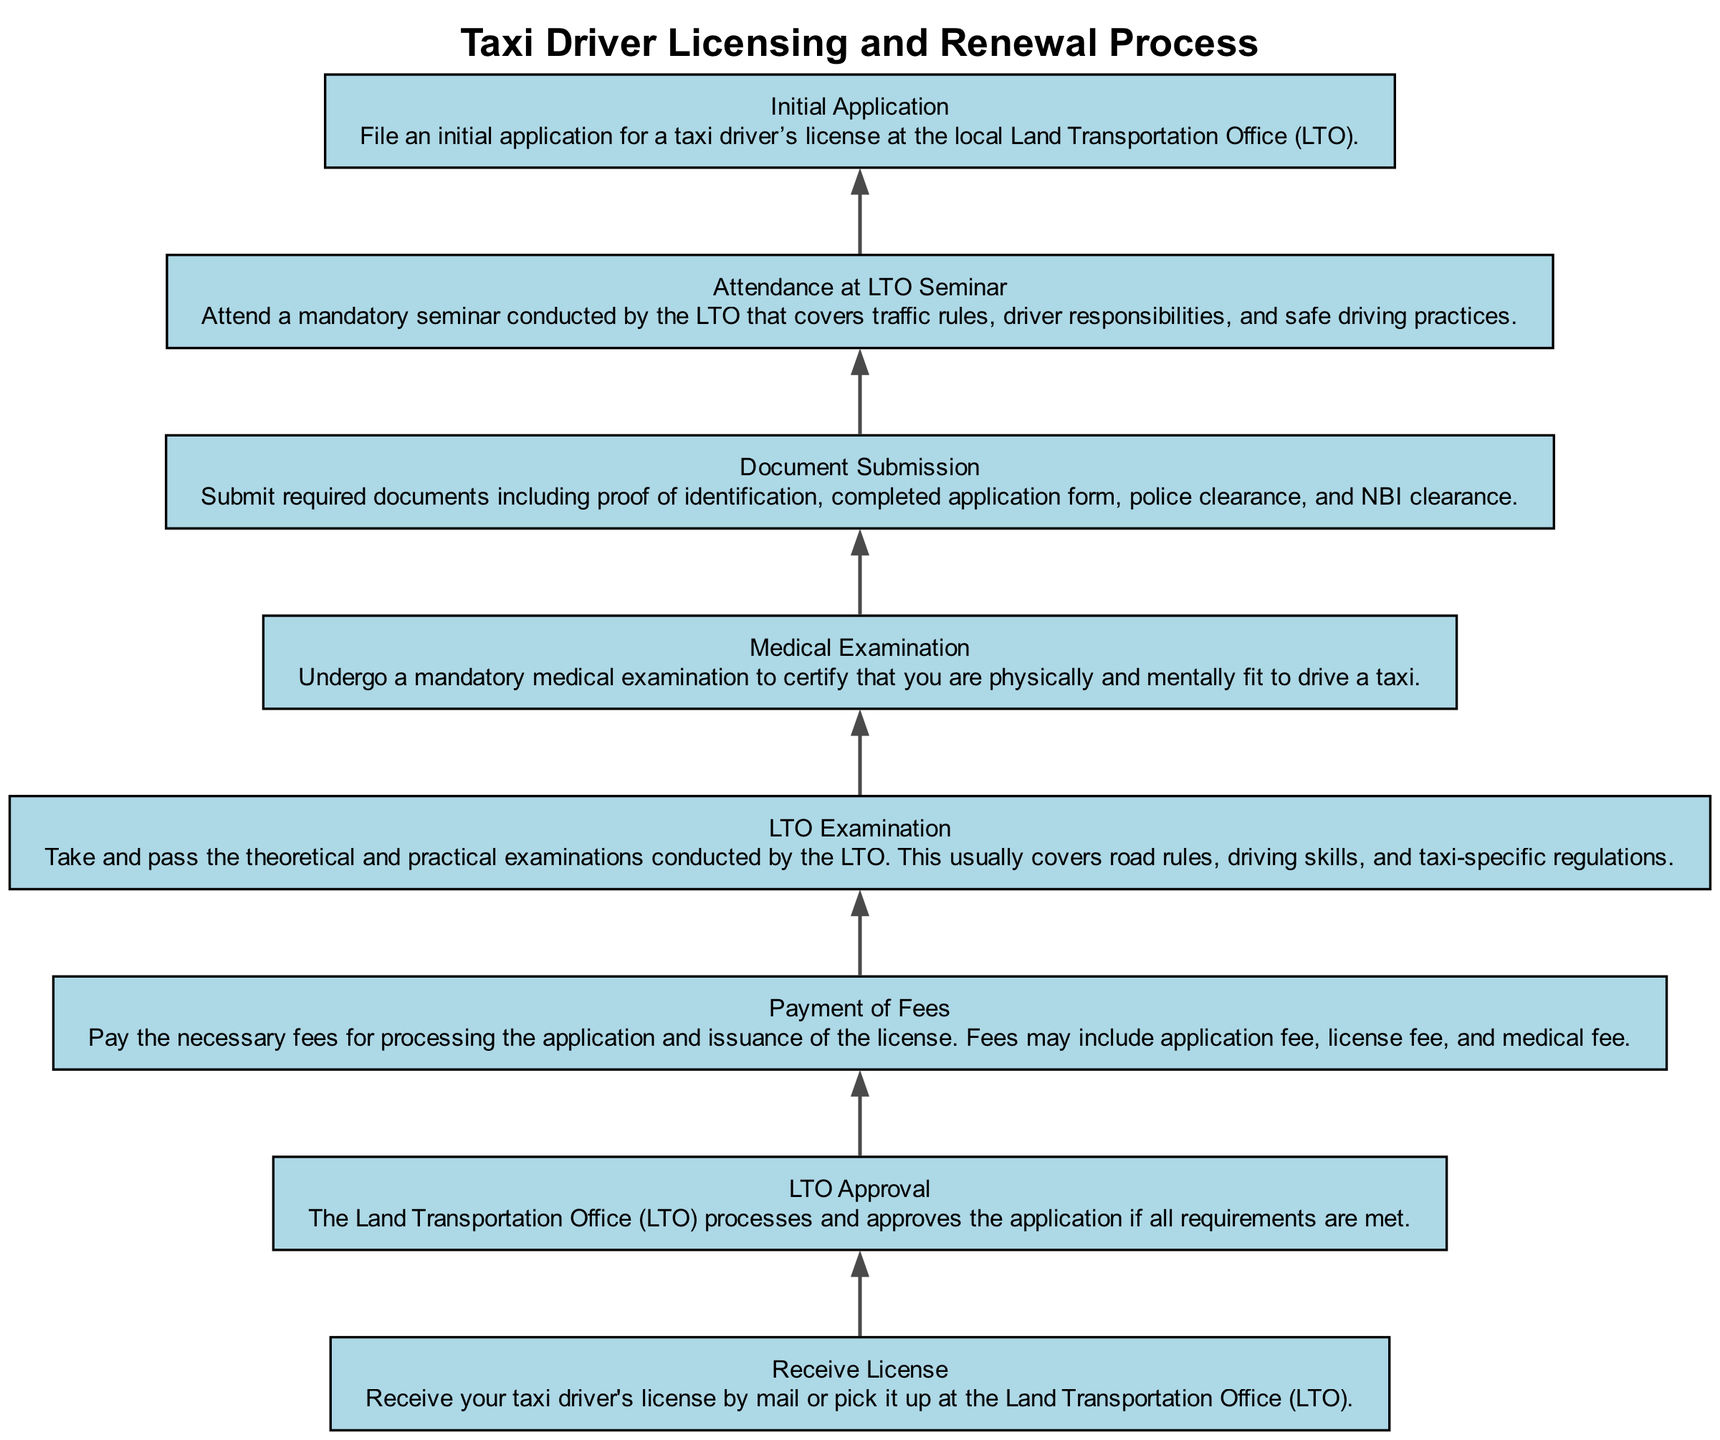What is the first step in the licensing process? The first step in the process is "Initial Application," where the taxi driver files their application at the local Land Transportation Office. This is the starting point indicated at the bottom of the flow chart.
Answer: Initial Application How many steps are there in the process? The flow chart contains a total of eight steps, starting from "Initial Application" to "Receive License." Each element represents a distinct part of the process, making it easy to count.
Answer: Eight What documents are required during Document Submission? The required documents during Document Submission include proof of identification, completed application form, police clearance, and NBI clearance. These documents are crucial to proceed further in the licensing process.
Answer: Proof of identification, completed application form, police clearance, NBI clearance Which step directly follows the Medical Examination? After completing the Medical Examination, the next step is "Attendance at LTO Seminar." This indicates a sequence in the process where following the medical check, you have to attend a seminar.
Answer: Attendance at LTO Seminar What is the final outcome of this process? The final outcome of this licensing process is "Receive License," where the driver either receives their license by mail or picks it up from the Land Transportation Office. This outcome is the goal of the entire flow.
Answer: Receive License Which two steps are required before attending the LTO Seminar? Before attending the LTO Seminar, the steps that must be completed are the "Document Submission" and "Medical Examination." Both of these steps are prerequisites for the seminar, as detailed in the flow.
Answer: Document Submission and Medical Examination In what order must the examinations be completed? The order of the examinations is that the driver must first take the "Medical Examination," followed by the "LTO Examination." This sequence ensures that the driver is medically fit before testing their driving knowledge and skills.
Answer: Medical Examination, then LTO Examination Is payment required before the LTO Approval? Yes, the "Payment of Fees" must be completed before the "LTO Approval." This indicates that financial obligations are a prerequisite for the application to be processed by the LTO effectively.
Answer: Yes 